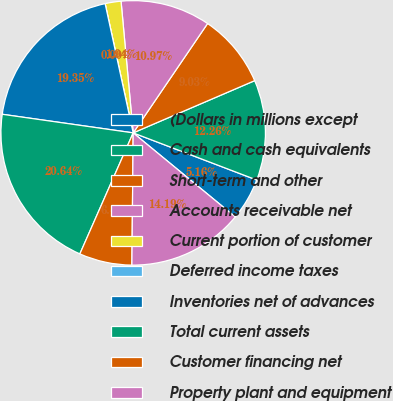Convert chart. <chart><loc_0><loc_0><loc_500><loc_500><pie_chart><fcel>(Dollars in millions except<fcel>Cash and cash equivalents<fcel>Short-term and other<fcel>Accounts receivable net<fcel>Current portion of customer<fcel>Deferred income taxes<fcel>Inventories net of advances<fcel>Total current assets<fcel>Customer financing net<fcel>Property plant and equipment<nl><fcel>5.16%<fcel>12.26%<fcel>9.03%<fcel>10.97%<fcel>1.94%<fcel>0.0%<fcel>19.35%<fcel>20.64%<fcel>6.45%<fcel>14.19%<nl></chart> 